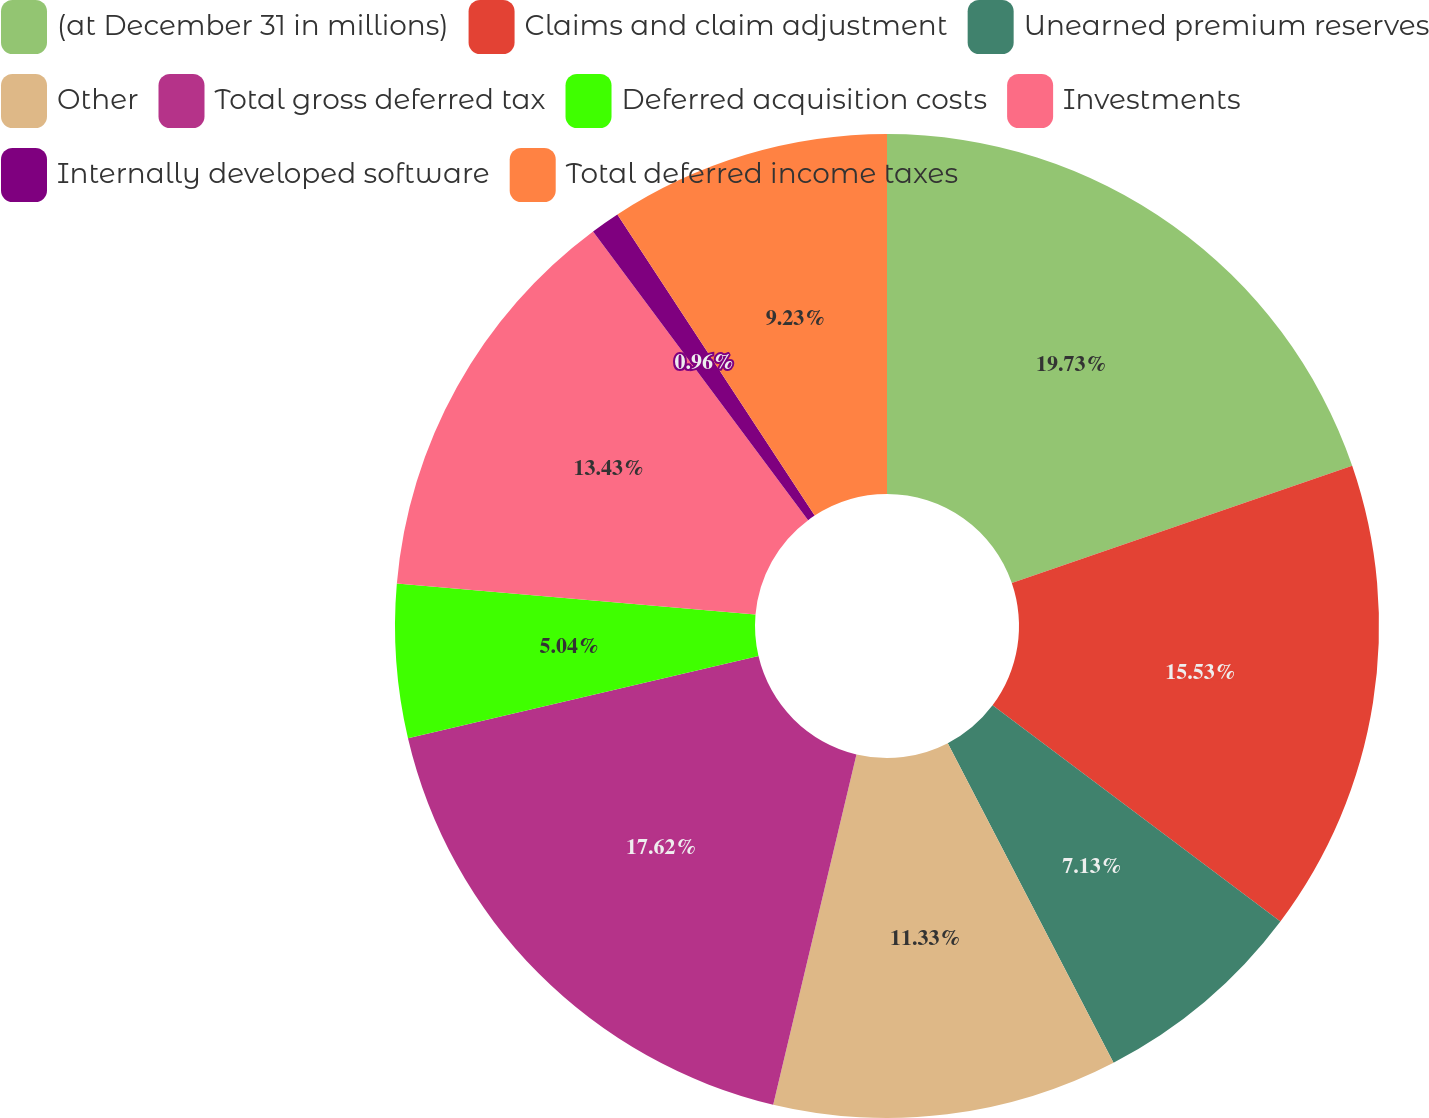<chart> <loc_0><loc_0><loc_500><loc_500><pie_chart><fcel>(at December 31 in millions)<fcel>Claims and claim adjustment<fcel>Unearned premium reserves<fcel>Other<fcel>Total gross deferred tax<fcel>Deferred acquisition costs<fcel>Investments<fcel>Internally developed software<fcel>Total deferred income taxes<nl><fcel>19.72%<fcel>15.53%<fcel>7.13%<fcel>11.33%<fcel>17.62%<fcel>5.04%<fcel>13.43%<fcel>0.96%<fcel>9.23%<nl></chart> 